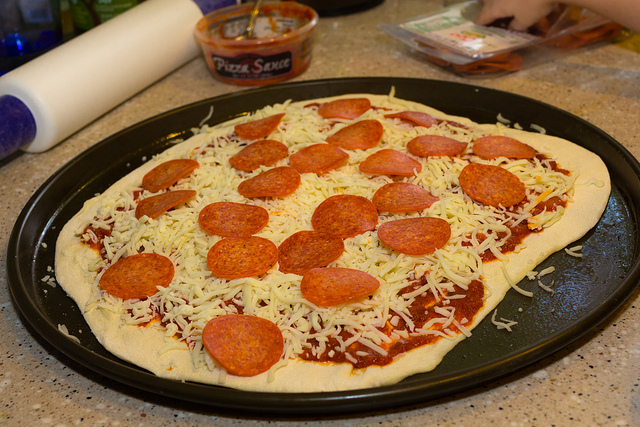Read and extract the text from this image. PIZZA Sawce 